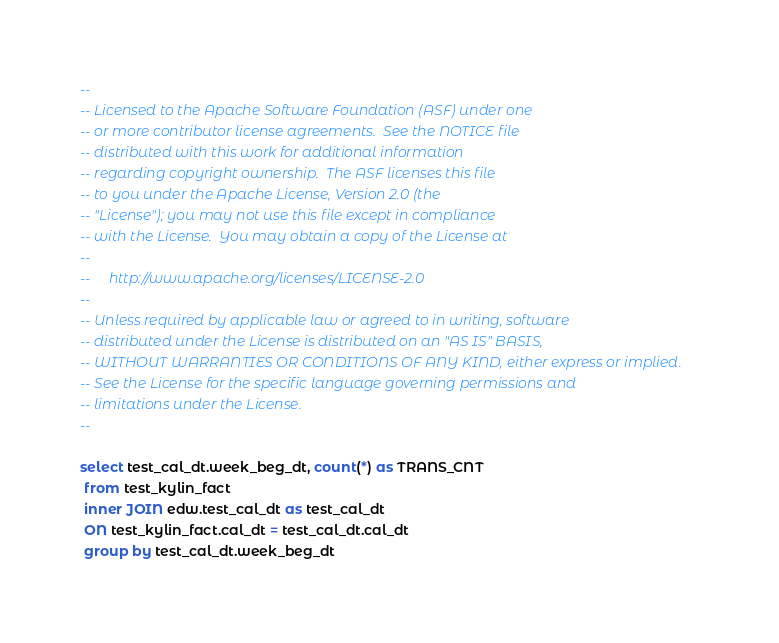<code> <loc_0><loc_0><loc_500><loc_500><_SQL_>--
-- Licensed to the Apache Software Foundation (ASF) under one
-- or more contributor license agreements.  See the NOTICE file
-- distributed with this work for additional information
-- regarding copyright ownership.  The ASF licenses this file
-- to you under the Apache License, Version 2.0 (the
-- "License"); you may not use this file except in compliance
-- with the License.  You may obtain a copy of the License at
--
--     http://www.apache.org/licenses/LICENSE-2.0
--
-- Unless required by applicable law or agreed to in writing, software
-- distributed under the License is distributed on an "AS IS" BASIS,
-- WITHOUT WARRANTIES OR CONDITIONS OF ANY KIND, either express or implied.
-- See the License for the specific language governing permissions and
-- limitations under the License.
--

select test_cal_dt.week_beg_dt, count(*) as TRANS_CNT 
 from test_kylin_fact 
 inner JOIN edw.test_cal_dt as test_cal_dt  
 ON test_kylin_fact.cal_dt = test_cal_dt.cal_dt 
 group by test_cal_dt.week_beg_dt 
</code> 